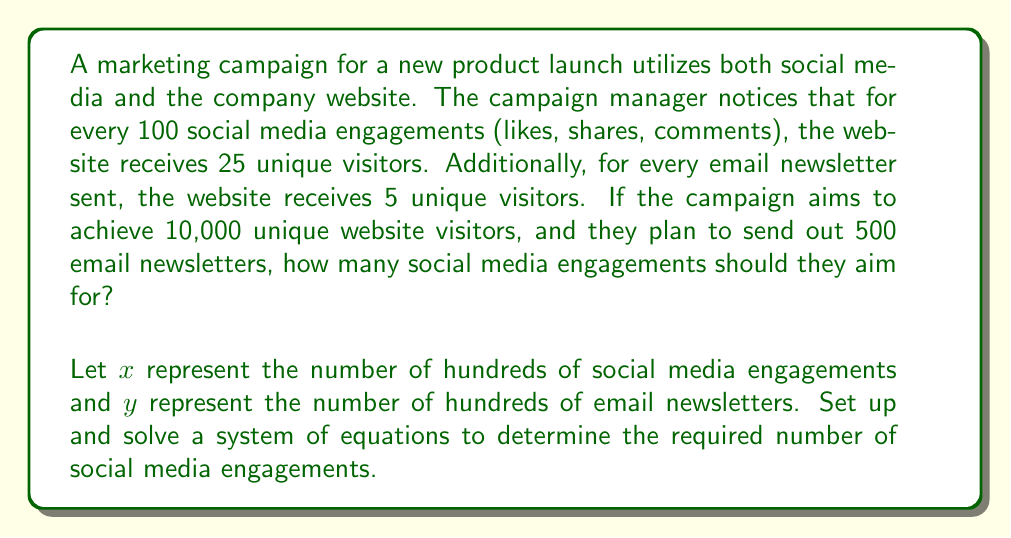Show me your answer to this math problem. Let's approach this step-by-step:

1. Define variables:
   $x$ = number of hundreds of social media engagements
   $y$ = number of hundreds of email newsletters

2. Set up the first equation based on the relationship between social media engagements and website visitors:
   $$25x + 5y = 100$$
   This equation represents that 25 visitors come from each hundred social media engagements, and 5 visitors come from each hundred email newsletters, totaling 100 visitors.

3. Set up the second equation based on the given information:
   $$y = 5$$
   We know they plan to send 500 email newsletters, which is 5 hundreds.

4. Substitute $y = 5$ into the first equation:
   $$25x + 5(5) = 100$$
   $$25x + 25 = 100$$

5. Solve for $x$:
   $$25x = 75$$
   $$x = 3$$

6. Interpret the result:
   $x = 3$ means 3 hundreds of social media engagements, which is 300 engagements.

7. Verify the solution:
   300 social media engagements produce $300 * 0.25 = 75$ visitors
   500 email newsletters produce $500 * 0.05 = 25$ visitors
   Total: 75 + 25 = 100 visitors (10,000 as required)
Answer: The marketing campaign should aim for 300 social media engagements to achieve the goal of 10,000 unique website visitors. 